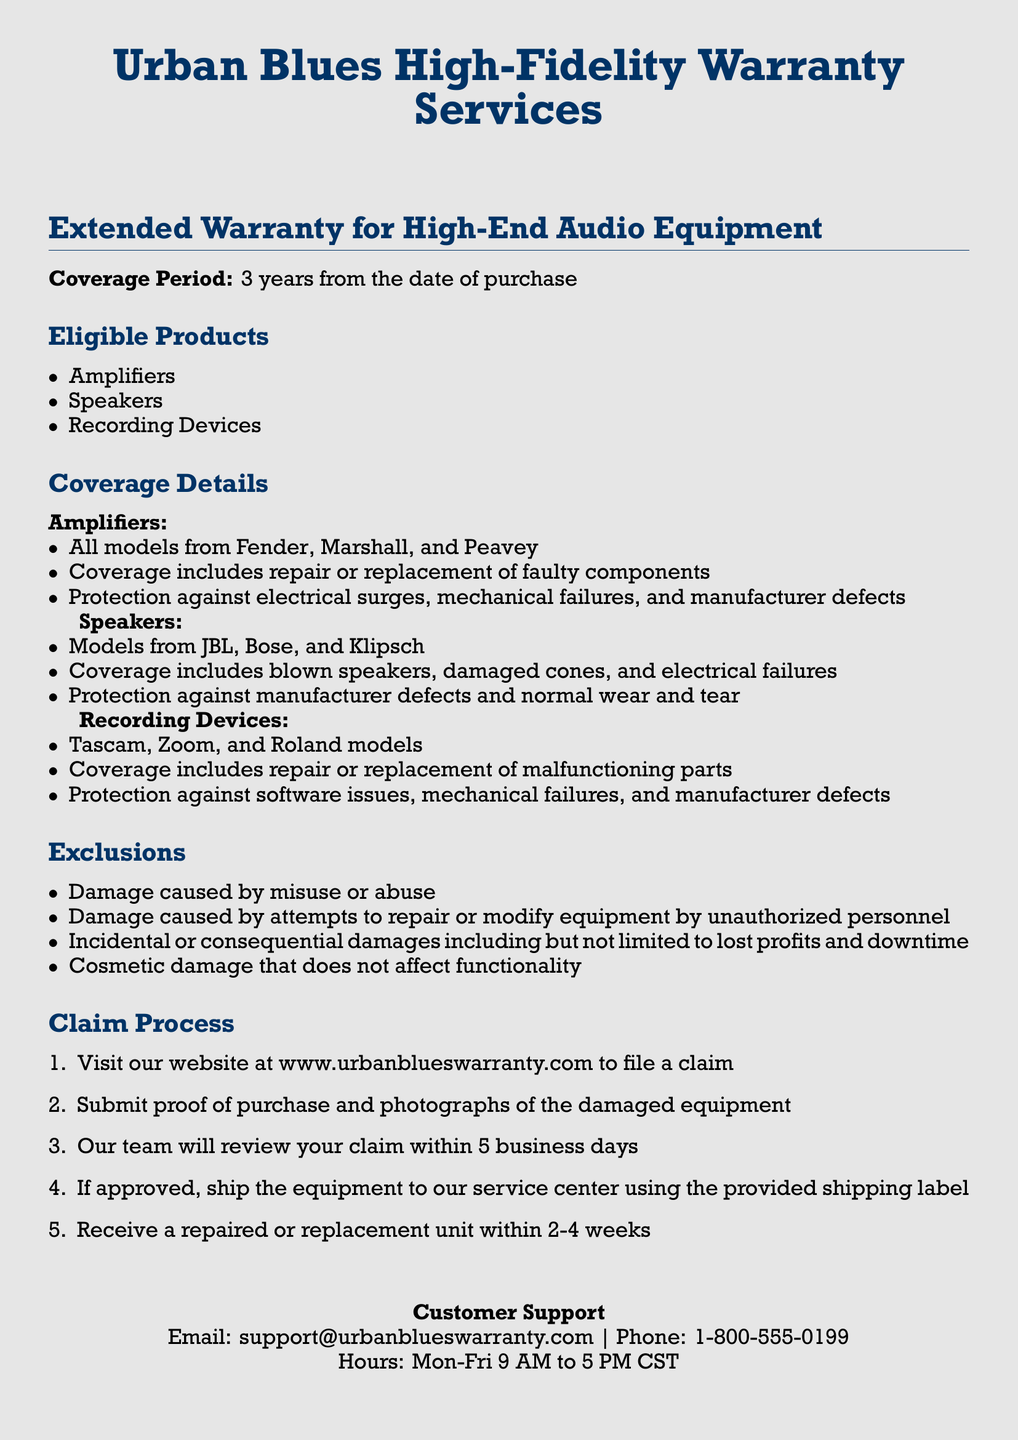what is the coverage period? The document states that the coverage period for the extended warranty is 3 years from the date of purchase.
Answer: 3 years which brand of amplifiers is covered? The warranty covers amplifiers from Fender, Marshall, and Peavey, as listed in the coverage details.
Answer: Fender, Marshall, Peavey what kind of damage is excluded from coverage? The document lists exclusions, which include damage caused by misuse or abuse.
Answer: Misuse or abuse how long will it take to receive a replacement unit after approval? The claim process outlines that after approval, a repaired or replacement unit will be received within 2-4 weeks.
Answer: 2-4 weeks what must a customer submit to file a claim? The claim process specifies that proof of purchase and photographs of the damaged equipment must be submitted.
Answer: Proof of purchase and photographs which recording devices are covered? The document states that Tascam, Zoom, and Roland models are eligible for coverage under the warranty.
Answer: Tascam, Zoom, Roland 